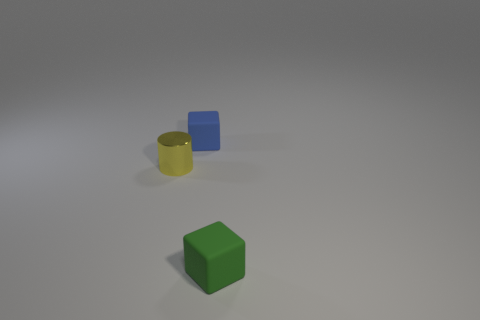There is a tiny object to the left of the small block that is behind the tiny yellow shiny cylinder; what number of yellow cylinders are on the left side of it?
Your answer should be compact. 0. What is the color of the tiny block on the right side of the tiny blue rubber block?
Your answer should be very brief. Green. There is a thing that is both behind the small green rubber thing and right of the tiny yellow metallic thing; what material is it?
Ensure brevity in your answer.  Rubber. There is a rubber block that is right of the tiny blue object; what number of small yellow metal cylinders are in front of it?
Ensure brevity in your answer.  0. What shape is the small yellow metallic object?
Your answer should be very brief. Cylinder. The other small thing that is made of the same material as the tiny green object is what shape?
Your response must be concise. Cube. There is a tiny object behind the yellow cylinder; does it have the same shape as the tiny yellow object?
Keep it short and to the point. No. What shape is the thing behind the metallic object?
Ensure brevity in your answer.  Cube. How many other blue cubes are the same size as the blue rubber cube?
Keep it short and to the point. 0. The small metallic cylinder is what color?
Keep it short and to the point. Yellow. 